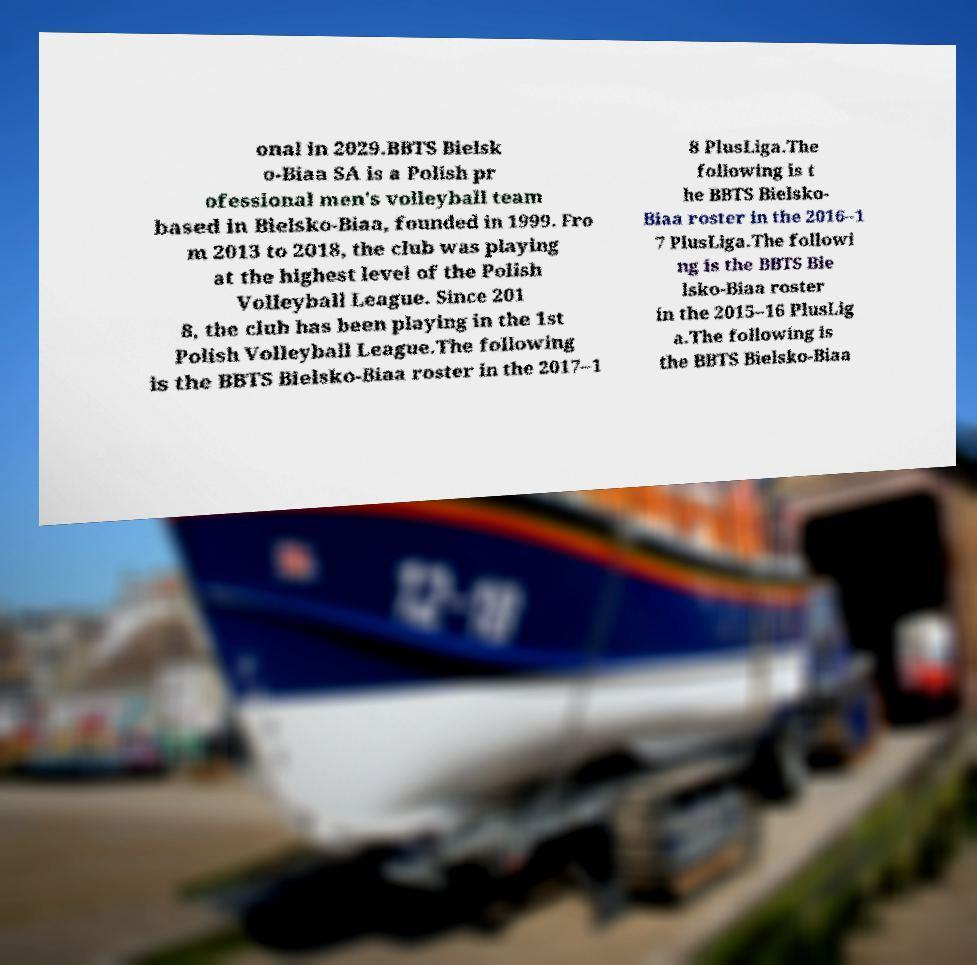Could you assist in decoding the text presented in this image and type it out clearly? onal in 2029.BBTS Bielsk o-Biaa SA is a Polish pr ofessional men's volleyball team based in Bielsko-Biaa, founded in 1999. Fro m 2013 to 2018, the club was playing at the highest level of the Polish Volleyball League. Since 201 8, the club has been playing in the 1st Polish Volleyball League.The following is the BBTS Bielsko-Biaa roster in the 2017–1 8 PlusLiga.The following is t he BBTS Bielsko- Biaa roster in the 2016–1 7 PlusLiga.The followi ng is the BBTS Bie lsko-Biaa roster in the 2015–16 PlusLig a.The following is the BBTS Bielsko-Biaa 